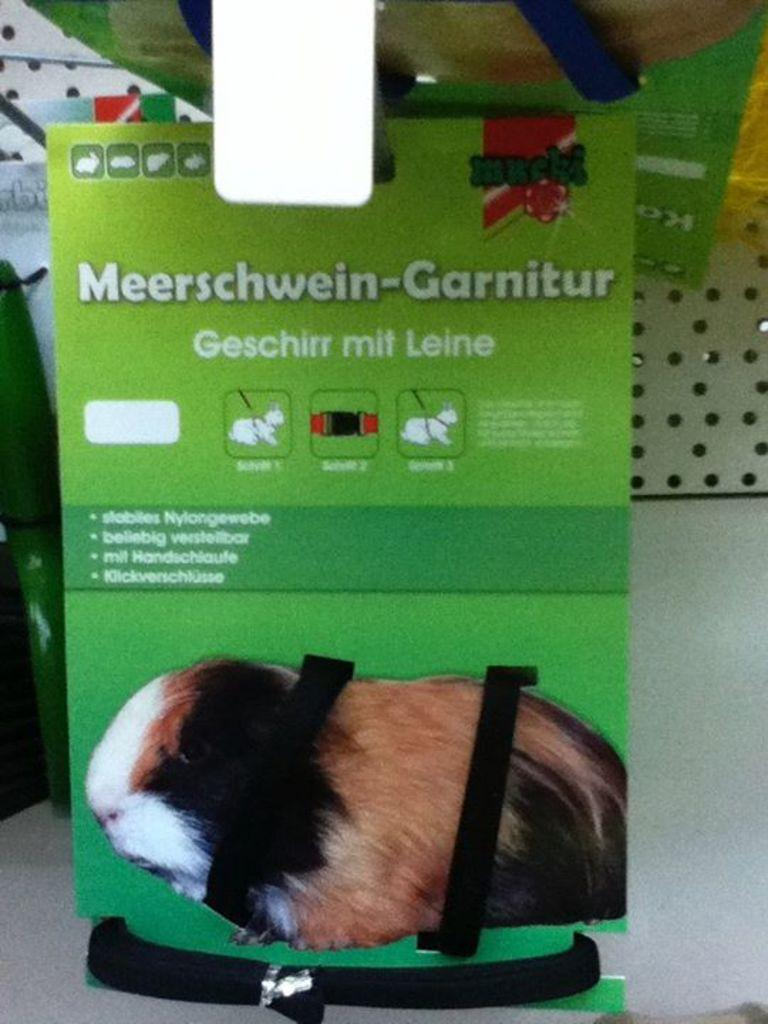What is the main object in the image? There is an advertisement board in the image. What is the background of the image made of? There is a wall in the image. What is the surface on which the advertisement board and wall are placed? There is a floor in the image. How many fields can be seen in the image? There are no fields present in the image; it features an advertisement board, a wall, and a floor. 